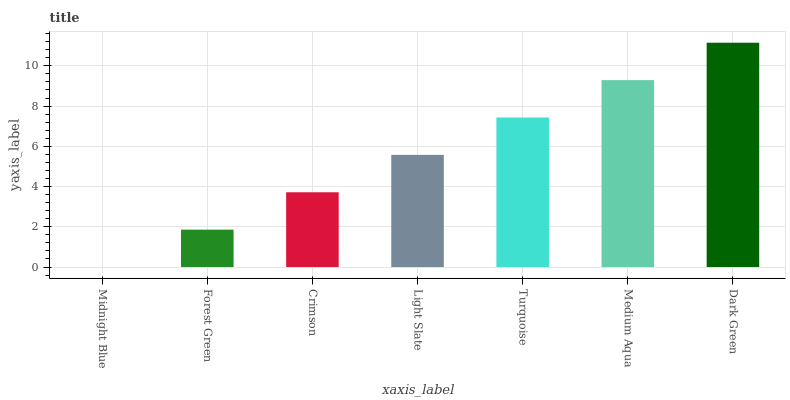Is Midnight Blue the minimum?
Answer yes or no. Yes. Is Dark Green the maximum?
Answer yes or no. Yes. Is Forest Green the minimum?
Answer yes or no. No. Is Forest Green the maximum?
Answer yes or no. No. Is Forest Green greater than Midnight Blue?
Answer yes or no. Yes. Is Midnight Blue less than Forest Green?
Answer yes or no. Yes. Is Midnight Blue greater than Forest Green?
Answer yes or no. No. Is Forest Green less than Midnight Blue?
Answer yes or no. No. Is Light Slate the high median?
Answer yes or no. Yes. Is Light Slate the low median?
Answer yes or no. Yes. Is Midnight Blue the high median?
Answer yes or no. No. Is Medium Aqua the low median?
Answer yes or no. No. 